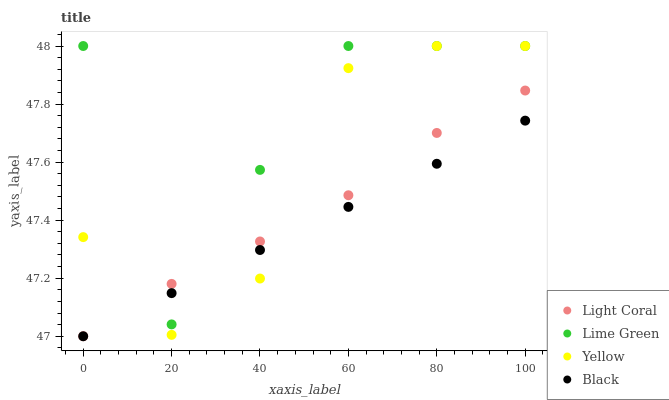Does Black have the minimum area under the curve?
Answer yes or no. Yes. Does Lime Green have the maximum area under the curve?
Answer yes or no. Yes. Does Lime Green have the minimum area under the curve?
Answer yes or no. No. Does Black have the maximum area under the curve?
Answer yes or no. No. Is Black the smoothest?
Answer yes or no. Yes. Is Lime Green the roughest?
Answer yes or no. Yes. Is Lime Green the smoothest?
Answer yes or no. No. Is Black the roughest?
Answer yes or no. No. Does Light Coral have the lowest value?
Answer yes or no. Yes. Does Lime Green have the lowest value?
Answer yes or no. No. Does Yellow have the highest value?
Answer yes or no. Yes. Does Black have the highest value?
Answer yes or no. No. Does Yellow intersect Lime Green?
Answer yes or no. Yes. Is Yellow less than Lime Green?
Answer yes or no. No. Is Yellow greater than Lime Green?
Answer yes or no. No. 